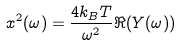Convert formula to latex. <formula><loc_0><loc_0><loc_500><loc_500>x ^ { 2 } ( \omega ) = \frac { 4 k _ { B } T } { \omega ^ { 2 } } \Re ( Y ( \omega ) )</formula> 